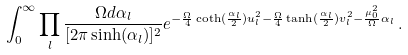Convert formula to latex. <formula><loc_0><loc_0><loc_500><loc_500>\int _ { 0 } ^ { \infty } \prod _ { l } \frac { \Omega d \alpha _ { l } } { [ 2 \pi \sinh ( \alpha _ { l } ) ] ^ { 2 } } e ^ { - \frac { \Omega } { 4 } \coth ( \frac { \alpha _ { l } } { 2 } ) { u _ { l } ^ { 2 } } - \frac { \Omega } { 4 } \tanh ( \frac { \alpha _ { l } } { 2 } ) { v _ { l } ^ { 2 } } - \frac { \mu _ { 0 } ^ { 2 } } { \Omega } \alpha _ { l } } \, .</formula> 